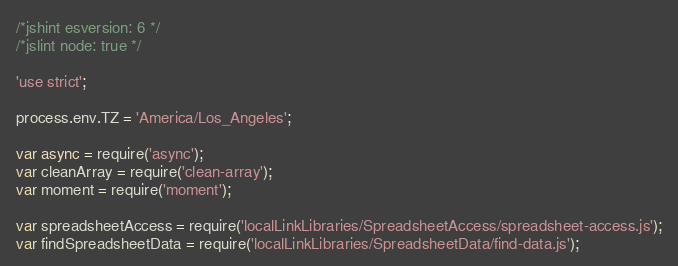Convert code to text. <code><loc_0><loc_0><loc_500><loc_500><_JavaScript_>/*jshint esversion: 6 */
/*jslint node: true */

'use strict';

process.env.TZ = 'America/Los_Angeles';

var async = require('async');
var cleanArray = require('clean-array');
var moment = require('moment');

var spreadsheetAccess = require('localLinkLibraries/SpreadsheetAccess/spreadsheet-access.js');
var findSpreadsheetData = require('localLinkLibraries/SpreadsheetData/find-data.js');</code> 